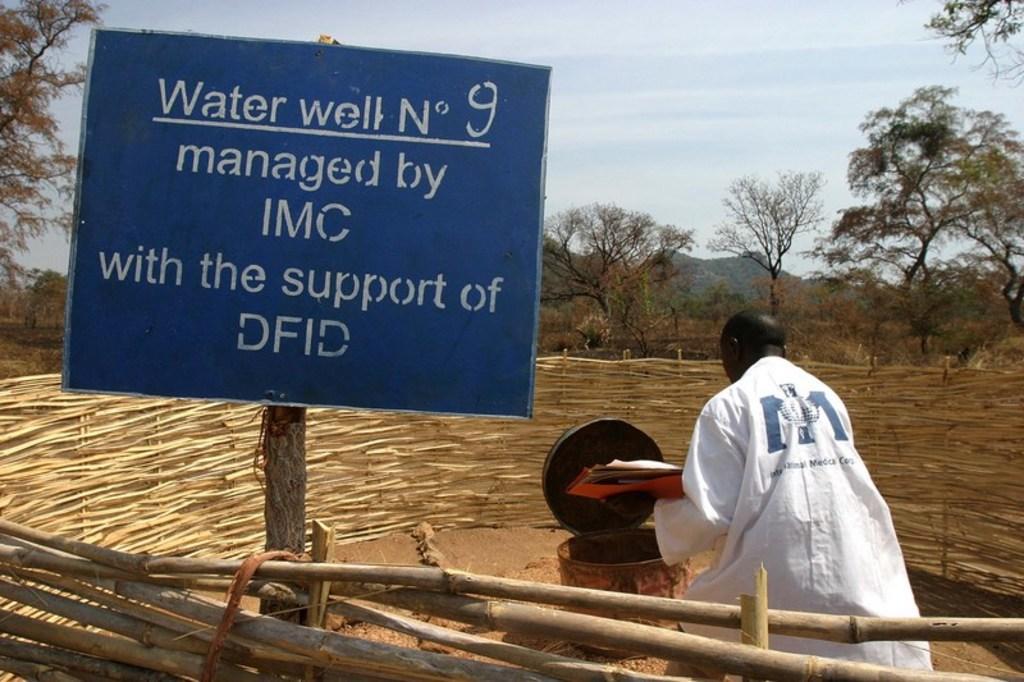Could you give a brief overview of what you see in this image? In this image we can see a signboard with some text on it. To the right side, we can see a person wearing a white shirt is holding a file in his hand. A container is placed on the ground. In the background, we can see a fence, a group of trees, mountain and the sky. 